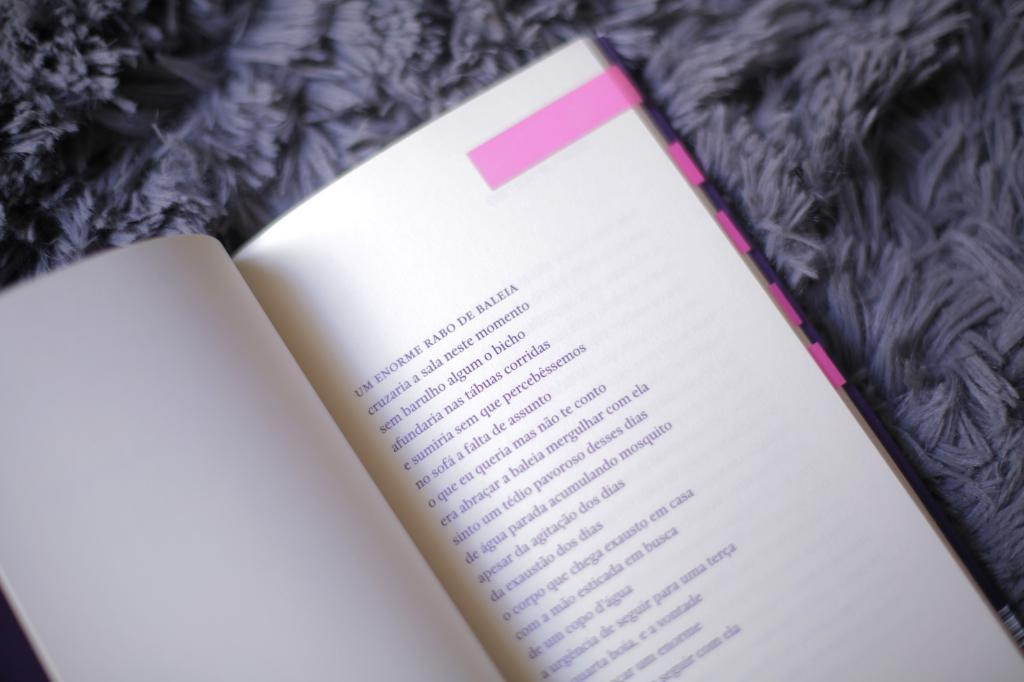<image>
Render a clear and concise summary of the photo. a book with the phrase Rabo De Baleia at the top 